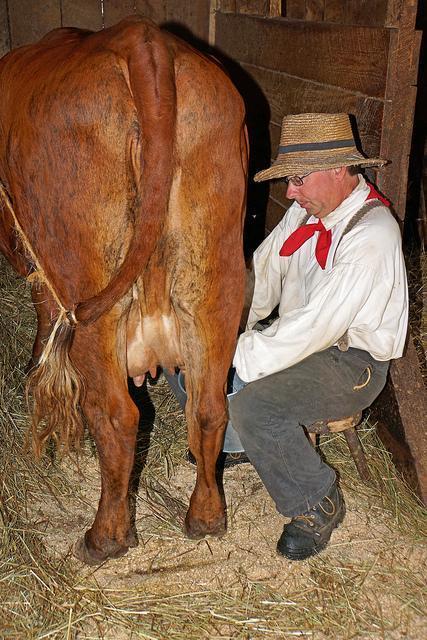Does the description: "The person is far away from the cow." accurately reflect the image?
Answer yes or no. No. Does the description: "The cow is in front of the person." accurately reflect the image?
Answer yes or no. Yes. 